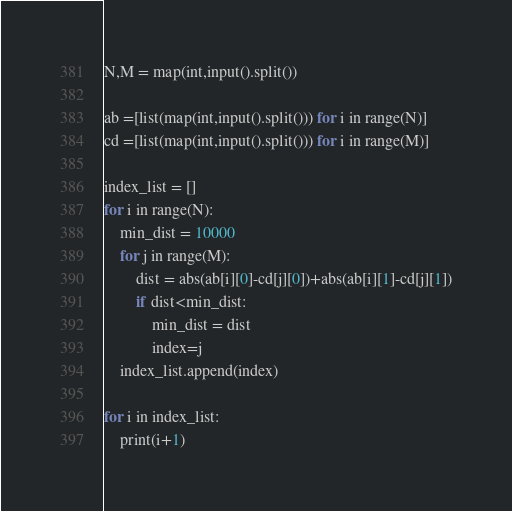<code> <loc_0><loc_0><loc_500><loc_500><_Python_>N,M = map(int,input().split())

ab =[list(map(int,input().split())) for i in range(N)]
cd =[list(map(int,input().split())) for i in range(M)]

index_list = []
for i in range(N):
    min_dist = 10000
    for j in range(M):
        dist = abs(ab[i][0]-cd[j][0])+abs(ab[i][1]-cd[j][1])
        if dist<min_dist:
            min_dist = dist
            index=j
    index_list.append(index)

for i in index_list:
    print(i+1)</code> 